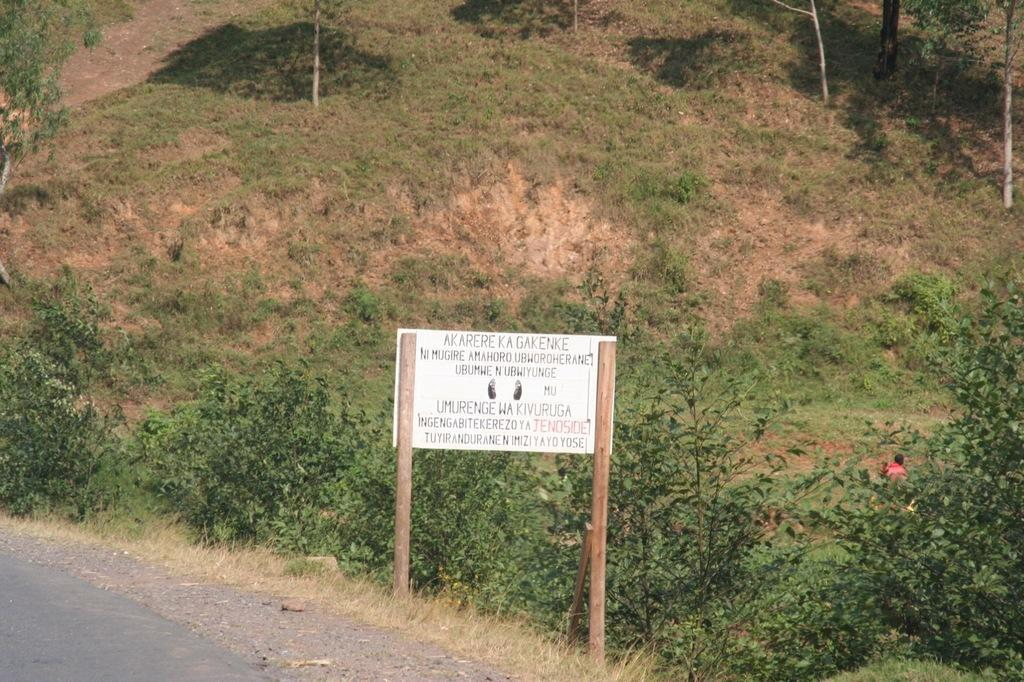What is the main structure in the image? There is a board attached to wooden poles in the image. Where is the image likely taken? The location appears to be a hill. What type of vegetation can be seen in the image? There is grass visible, as well as small trees. What is the condition of the grass in the image? There is both green grass and dried grass visible. Is there any indication of a path or road in the image? Yes, there appears to be a road in the image. What type of pie is being served on the hill in the image? There is no pie present in the image; it features a board attached to wooden poles on a hill with grass and small trees. Is there any indication of winter weather in the image? No, there is no indication of winter weather in the image; the vegetation and road suggest a more temperate climate. 